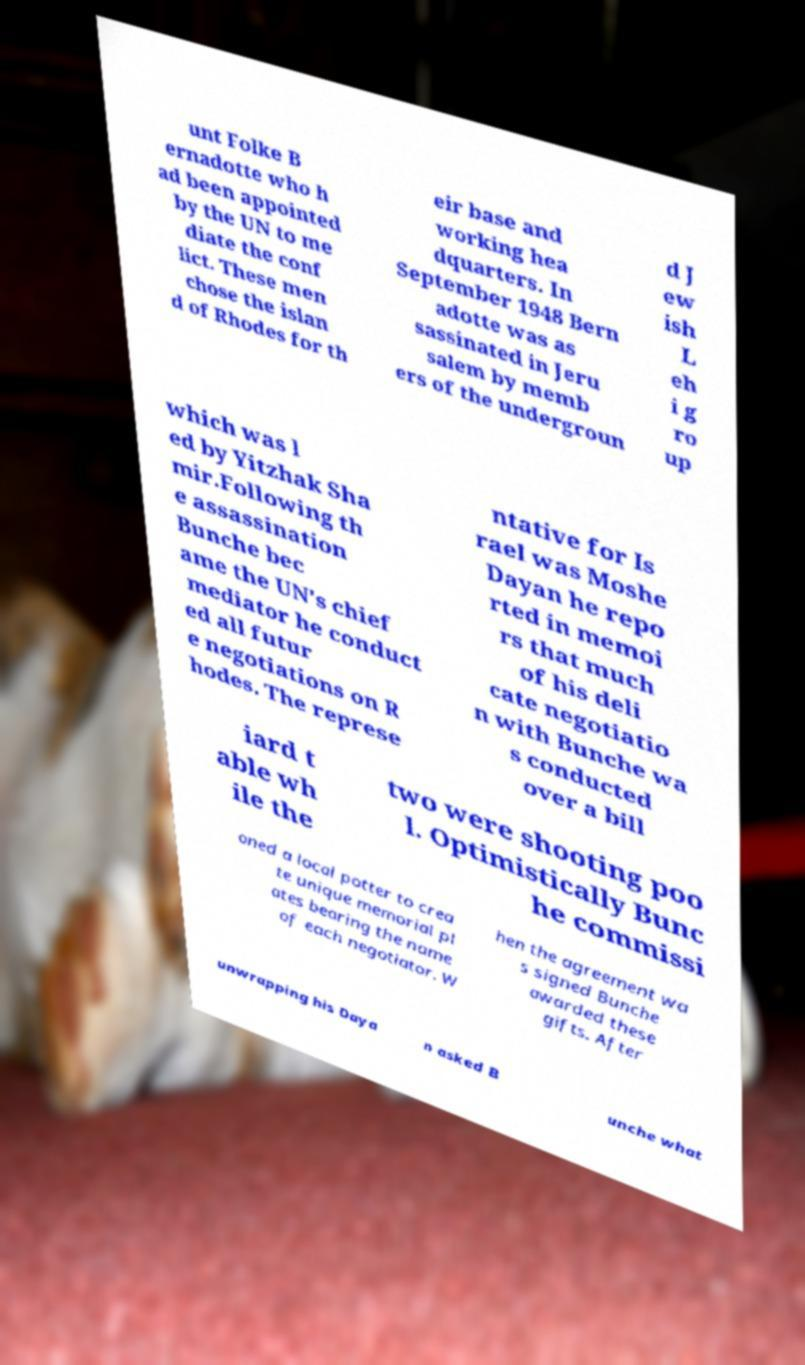Can you read and provide the text displayed in the image?This photo seems to have some interesting text. Can you extract and type it out for me? unt Folke B ernadotte who h ad been appointed by the UN to me diate the conf lict. These men chose the islan d of Rhodes for th eir base and working hea dquarters. In September 1948 Bern adotte was as sassinated in Jeru salem by memb ers of the undergroun d J ew ish L eh i g ro up which was l ed by Yitzhak Sha mir.Following th e assassination Bunche bec ame the UN's chief mediator he conduct ed all futur e negotiations on R hodes. The represe ntative for Is rael was Moshe Dayan he repo rted in memoi rs that much of his deli cate negotiatio n with Bunche wa s conducted over a bill iard t able wh ile the two were shooting poo l. Optimistically Bunc he commissi oned a local potter to crea te unique memorial pl ates bearing the name of each negotiator. W hen the agreement wa s signed Bunche awarded these gifts. After unwrapping his Daya n asked B unche what 